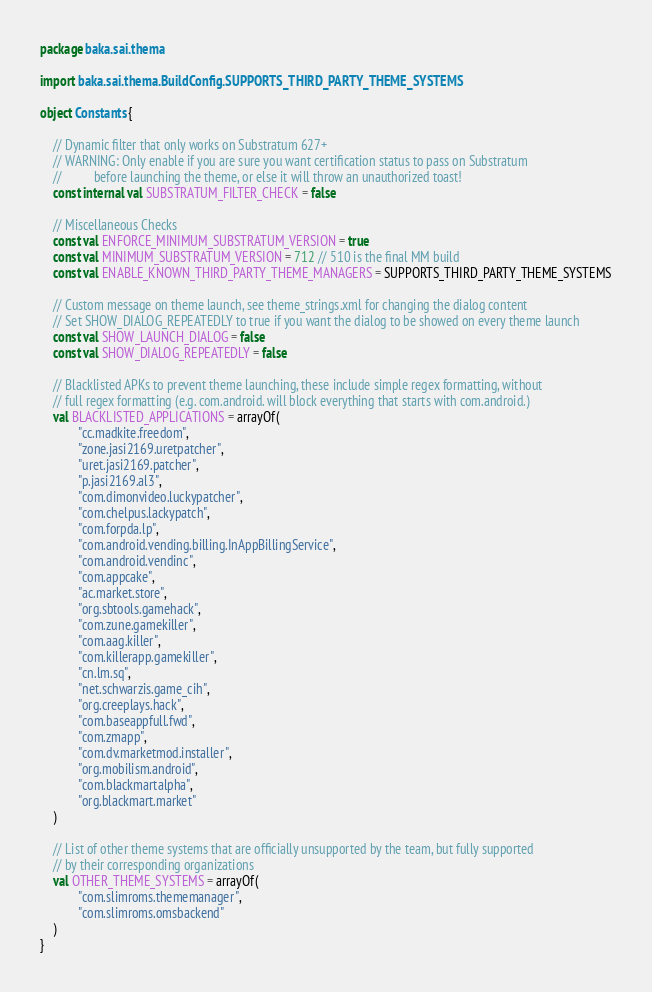Convert code to text. <code><loc_0><loc_0><loc_500><loc_500><_Kotlin_>package baka.sai.thema

import baka.sai.thema.BuildConfig.SUPPORTS_THIRD_PARTY_THEME_SYSTEMS

object Constants {

    // Dynamic filter that only works on Substratum 627+
    // WARNING: Only enable if you are sure you want certification status to pass on Substratum
    //          before launching the theme, or else it will throw an unauthorized toast!
    const internal val SUBSTRATUM_FILTER_CHECK = false

    // Miscellaneous Checks
    const val ENFORCE_MINIMUM_SUBSTRATUM_VERSION = true
    const val MINIMUM_SUBSTRATUM_VERSION = 712 // 510 is the final MM build
    const val ENABLE_KNOWN_THIRD_PARTY_THEME_MANAGERS = SUPPORTS_THIRD_PARTY_THEME_SYSTEMS

    // Custom message on theme launch, see theme_strings.xml for changing the dialog content
    // Set SHOW_DIALOG_REPEATEDLY to true if you want the dialog to be showed on every theme launch
    const val SHOW_LAUNCH_DIALOG = false
    const val SHOW_DIALOG_REPEATEDLY = false

    // Blacklisted APKs to prevent theme launching, these include simple regex formatting, without
    // full regex formatting (e.g. com.android. will block everything that starts with com.android.)
    val BLACKLISTED_APPLICATIONS = arrayOf(
            "cc.madkite.freedom",
            "zone.jasi2169.uretpatcher",
            "uret.jasi2169.patcher",
            "p.jasi2169.al3",
            "com.dimonvideo.luckypatcher",
            "com.chelpus.lackypatch",
            "com.forpda.lp",
            "com.android.vending.billing.InAppBillingService",
            "com.android.vendinc",
            "com.appcake",
            "ac.market.store",
            "org.sbtools.gamehack",
            "com.zune.gamekiller",
            "com.aag.killer",
            "com.killerapp.gamekiller",
            "cn.lm.sq",
            "net.schwarzis.game_cih",
            "org.creeplays.hack",
            "com.baseappfull.fwd",
            "com.zmapp",
            "com.dv.marketmod.installer",
            "org.mobilism.android",
            "com.blackmartalpha",
            "org.blackmart.market"
    )

    // List of other theme systems that are officially unsupported by the team, but fully supported
    // by their corresponding organizations
    val OTHER_THEME_SYSTEMS = arrayOf(
            "com.slimroms.thememanager",
            "com.slimroms.omsbackend"
    )
}
</code> 